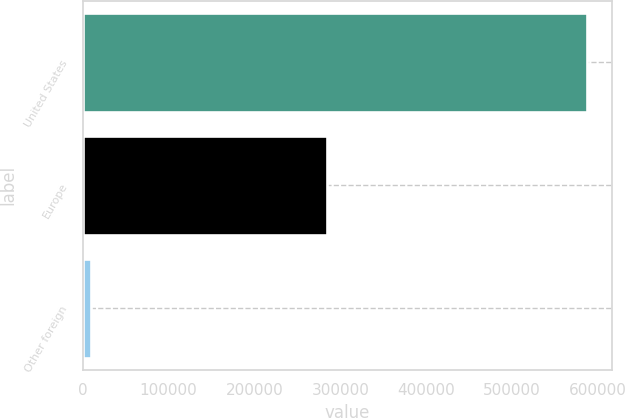Convert chart to OTSL. <chart><loc_0><loc_0><loc_500><loc_500><bar_chart><fcel>United States<fcel>Europe<fcel>Other foreign<nl><fcel>587592<fcel>284171<fcel>9627<nl></chart> 